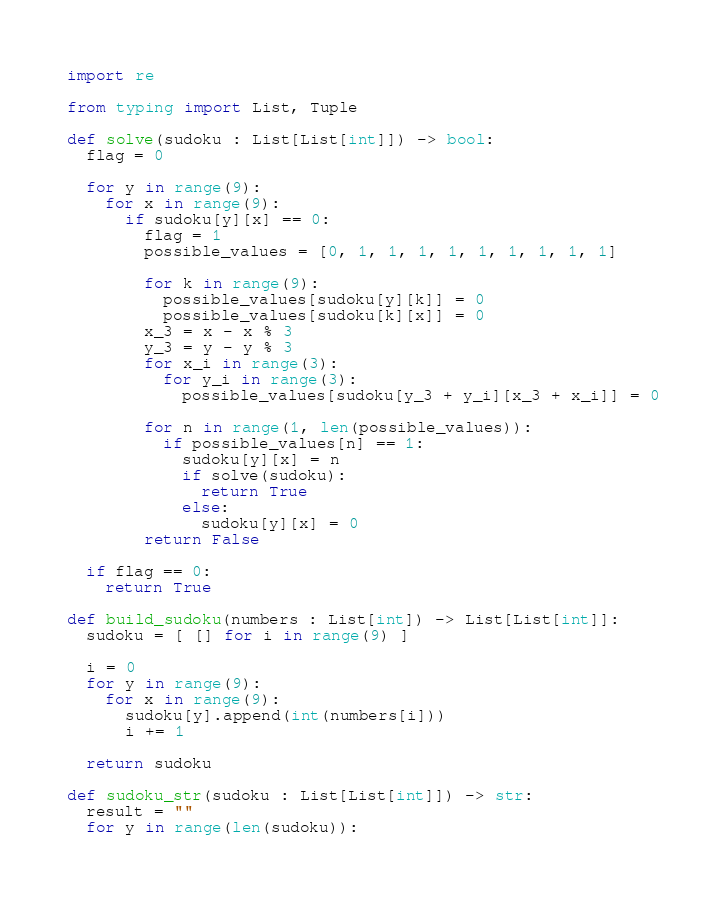<code> <loc_0><loc_0><loc_500><loc_500><_Python_>import re

from typing import List, Tuple

def solve(sudoku : List[List[int]]) -> bool:
  flag = 0
  
  for y in range(9):
    for x in range(9):
      if sudoku[y][x] == 0:
        flag = 1
        possible_values = [0, 1, 1, 1, 1, 1, 1, 1, 1, 1]

        for k in range(9):
          possible_values[sudoku[y][k]] = 0
          possible_values[sudoku[k][x]] = 0
        x_3 = x - x % 3
        y_3 = y - y % 3
        for x_i in range(3):
          for y_i in range(3):
            possible_values[sudoku[y_3 + y_i][x_3 + x_i]] = 0

        for n in range(1, len(possible_values)):
          if possible_values[n] == 1:
            sudoku[y][x] = n
            if solve(sudoku):
              return True
            else:
              sudoku[y][x] = 0
        return False
  
  if flag == 0:
    return True

def build_sudoku(numbers : List[int]) -> List[List[int]]:
  sudoku = [ [] for i in range(9) ]

  i = 0
  for y in range(9):
    for x in range(9):
      sudoku[y].append(int(numbers[i]))
      i += 1

  return sudoku

def sudoku_str(sudoku : List[List[int]]) -> str:
  result = ""
  for y in range(len(sudoku)):</code> 